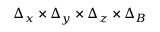Convert formula to latex. <formula><loc_0><loc_0><loc_500><loc_500>\Delta _ { x } \times \Delta _ { y } \times \Delta _ { z } \times \Delta _ { B }</formula> 